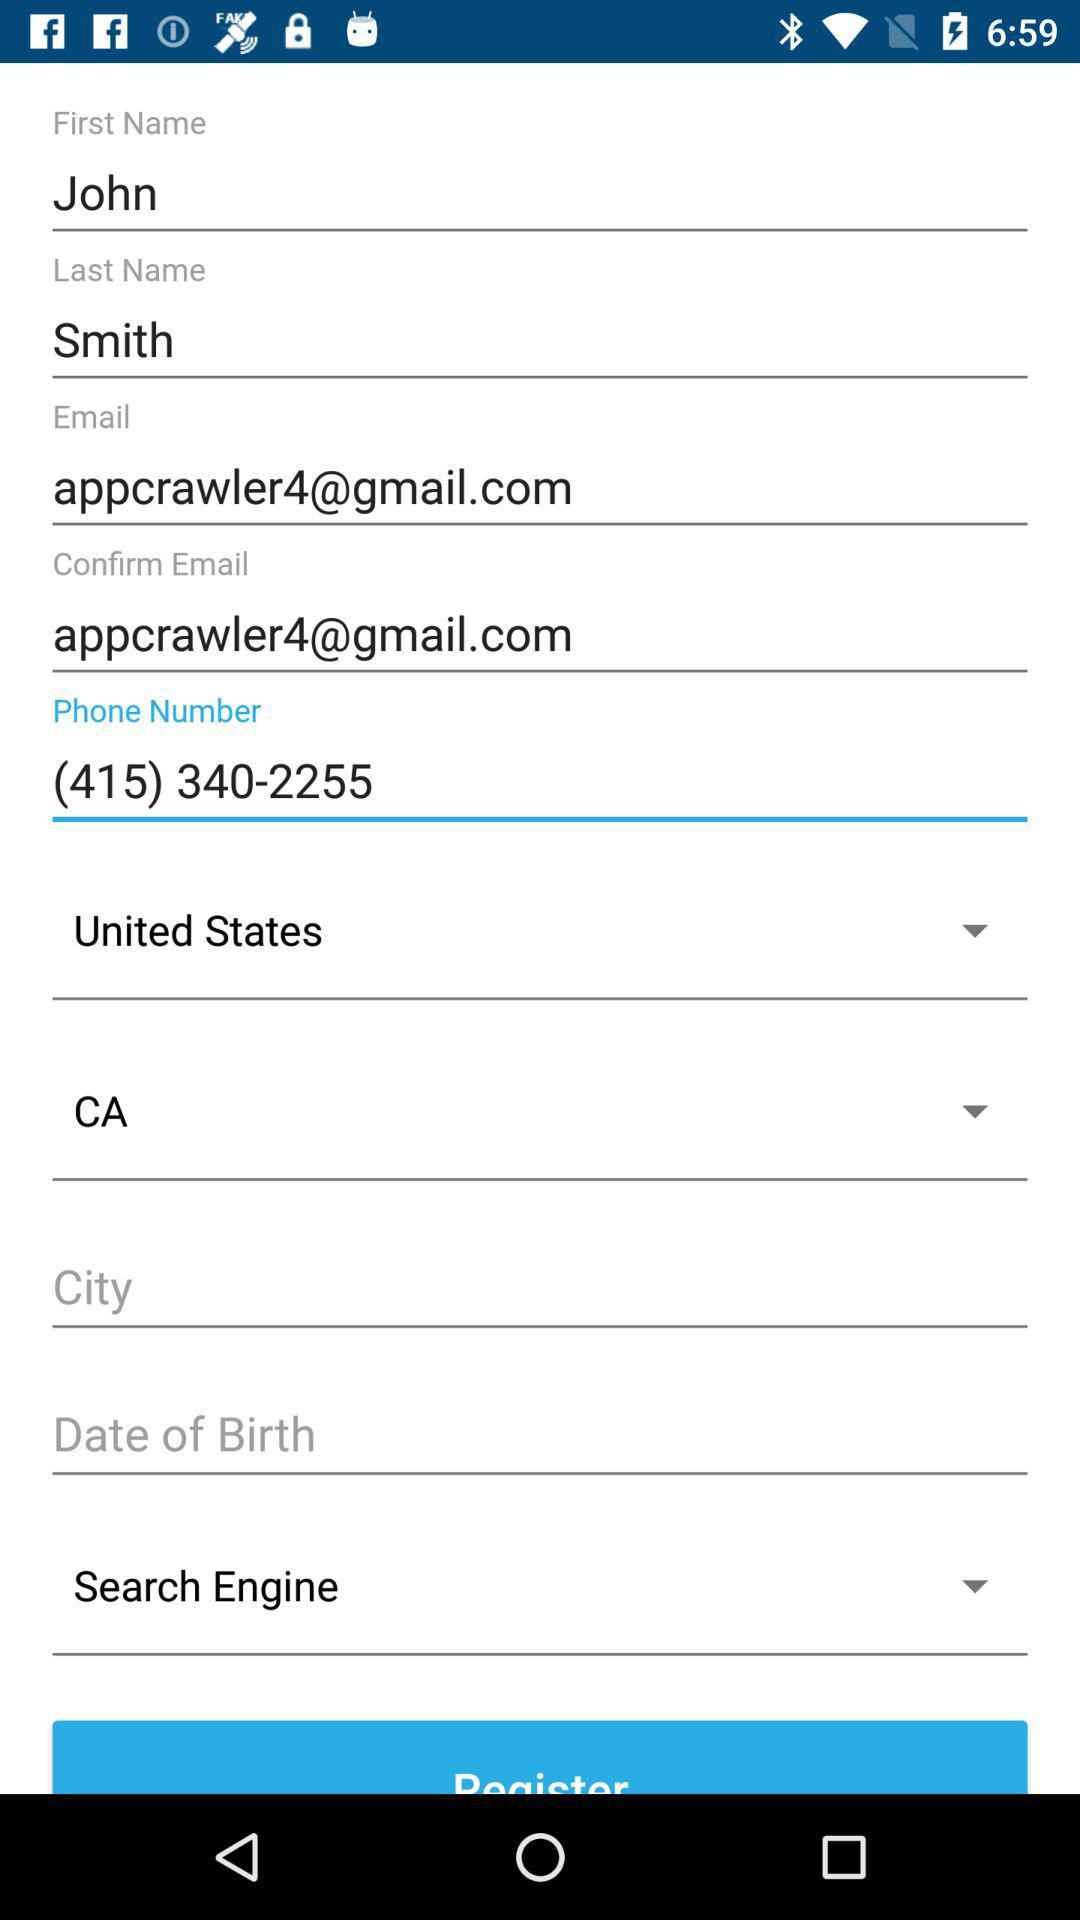What is the phone number? The phone number is (415) 340-2255. 